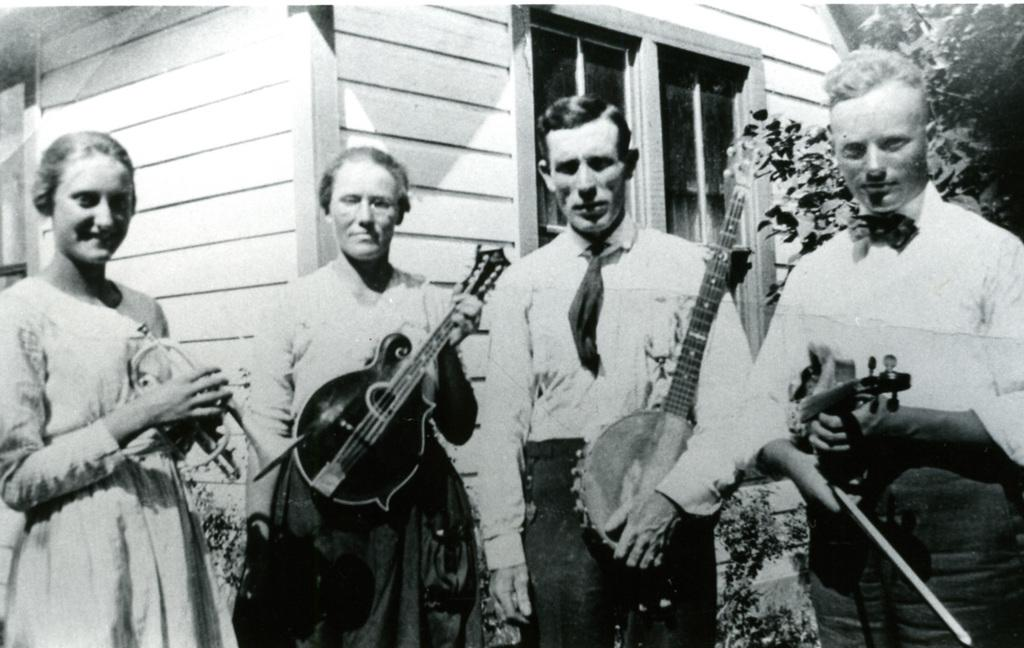What type of picture is the image? The image is an old black and white picture. How many people are in the image? There are four people in the image. What are the people doing in the image? The people are standing on the floor and holding music instruments. What can be seen in the background of the image? There are trees, a window, and a house visible in the background. What type of prison can be seen in the background of the image? There is no prison visible in the background of the image; it features trees, a window, and a house. How does the current affect the people in the image? The image is a black and white picture, so there is no reference to a current or any electrical elements in the image. 